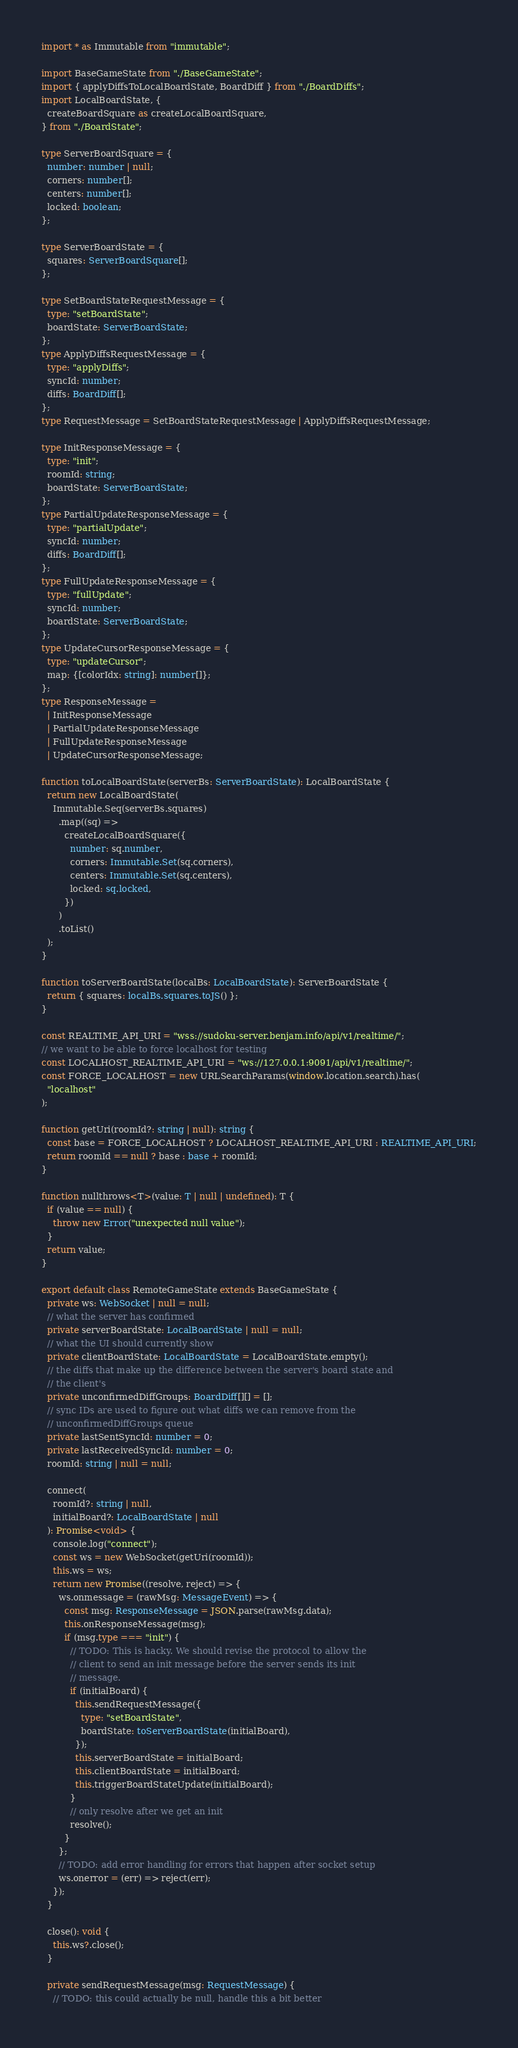<code> <loc_0><loc_0><loc_500><loc_500><_TypeScript_>import * as Immutable from "immutable";

import BaseGameState from "./BaseGameState";
import { applyDiffsToLocalBoardState, BoardDiff } from "./BoardDiffs";
import LocalBoardState, {
  createBoardSquare as createLocalBoardSquare,
} from "./BoardState";

type ServerBoardSquare = {
  number: number | null;
  corners: number[];
  centers: number[];
  locked: boolean;
};

type ServerBoardState = {
  squares: ServerBoardSquare[];
};

type SetBoardStateRequestMessage = {
  type: "setBoardState";
  boardState: ServerBoardState;
};
type ApplyDiffsRequestMessage = {
  type: "applyDiffs";
  syncId: number;
  diffs: BoardDiff[];
};
type RequestMessage = SetBoardStateRequestMessage | ApplyDiffsRequestMessage;

type InitResponseMessage = {
  type: "init";
  roomId: string;
  boardState: ServerBoardState;
};
type PartialUpdateResponseMessage = {
  type: "partialUpdate";
  syncId: number;
  diffs: BoardDiff[];
};
type FullUpdateResponseMessage = {
  type: "fullUpdate";
  syncId: number;
  boardState: ServerBoardState;
};
type UpdateCursorResponseMessage = {
  type: "updateCursor";
  map: {[colorIdx: string]: number[]};
};
type ResponseMessage =
  | InitResponseMessage
  | PartialUpdateResponseMessage
  | FullUpdateResponseMessage
  | UpdateCursorResponseMessage;

function toLocalBoardState(serverBs: ServerBoardState): LocalBoardState {
  return new LocalBoardState(
    Immutable.Seq(serverBs.squares)
      .map((sq) =>
        createLocalBoardSquare({
          number: sq.number,
          corners: Immutable.Set(sq.corners),
          centers: Immutable.Set(sq.centers),
          locked: sq.locked,
        })
      )
      .toList()
  );
}

function toServerBoardState(localBs: LocalBoardState): ServerBoardState {
  return { squares: localBs.squares.toJS() };
}

const REALTIME_API_URI = "wss://sudoku-server.benjam.info/api/v1/realtime/";
// we want to be able to force localhost for testing
const LOCALHOST_REALTIME_API_URI = "ws://127.0.0.1:9091/api/v1/realtime/";
const FORCE_LOCALHOST = new URLSearchParams(window.location.search).has(
  "localhost"
);

function getUri(roomId?: string | null): string {
  const base = FORCE_LOCALHOST ? LOCALHOST_REALTIME_API_URI : REALTIME_API_URI;
  return roomId == null ? base : base + roomId;
}

function nullthrows<T>(value: T | null | undefined): T {
  if (value == null) {
    throw new Error("unexpected null value");
  }
  return value;
}

export default class RemoteGameState extends BaseGameState {
  private ws: WebSocket | null = null;
  // what the server has confirmed
  private serverBoardState: LocalBoardState | null = null;
  // what the UI should currently show
  private clientBoardState: LocalBoardState = LocalBoardState.empty();
  // the diffs that make up the difference between the server's board state and
  // the client's
  private unconfirmedDiffGroups: BoardDiff[][] = [];
  // sync IDs are used to figure out what diffs we can remove from the
  // unconfirmedDiffGroups queue
  private lastSentSyncId: number = 0;
  private lastReceivedSyncId: number = 0;
  roomId: string | null = null;

  connect(
    roomId?: string | null,
    initialBoard?: LocalBoardState | null
  ): Promise<void> {
    console.log("connect");
    const ws = new WebSocket(getUri(roomId));
    this.ws = ws;
    return new Promise((resolve, reject) => {
      ws.onmessage = (rawMsg: MessageEvent) => {
        const msg: ResponseMessage = JSON.parse(rawMsg.data);
        this.onResponseMessage(msg);
        if (msg.type === "init") {
          // TODO: This is hacky. We should revise the protocol to allow the
          // client to send an init message before the server sends its init
          // message.
          if (initialBoard) {
            this.sendRequestMessage({
              type: "setBoardState",
              boardState: toServerBoardState(initialBoard),
            });
            this.serverBoardState = initialBoard;
            this.clientBoardState = initialBoard;
            this.triggerBoardStateUpdate(initialBoard);
          }
          // only resolve after we get an init
          resolve();
        }
      };
      // TODO: add error handling for errors that happen after socket setup
      ws.onerror = (err) => reject(err);
    });
  }

  close(): void {
    this.ws?.close();
  }

  private sendRequestMessage(msg: RequestMessage) {
    // TODO: this could actually be null, handle this a bit better</code> 